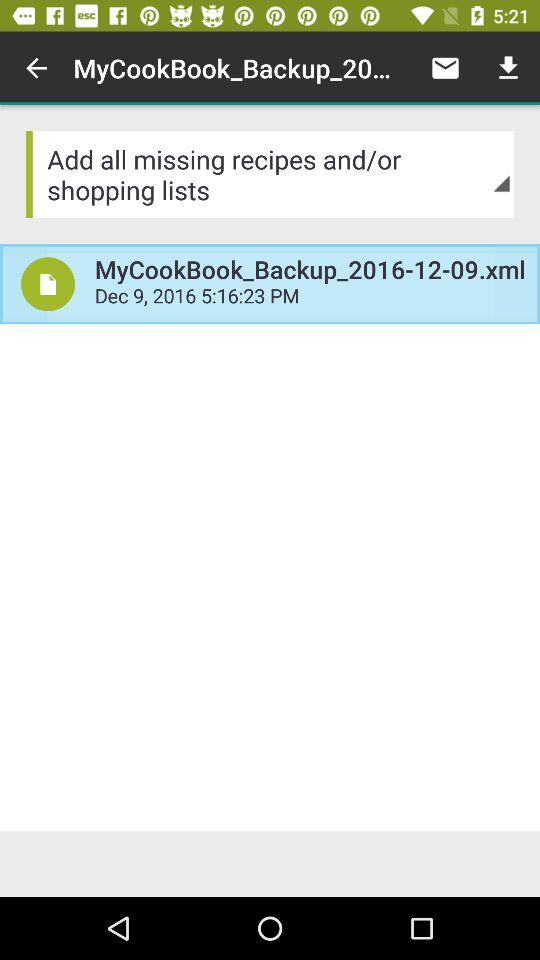What is the given date of the backup file? The given date is December 9, 2016. 